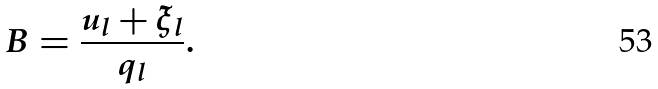<formula> <loc_0><loc_0><loc_500><loc_500>B = \frac { u _ { l } + \xi _ { l } } { q _ { l } } .</formula> 